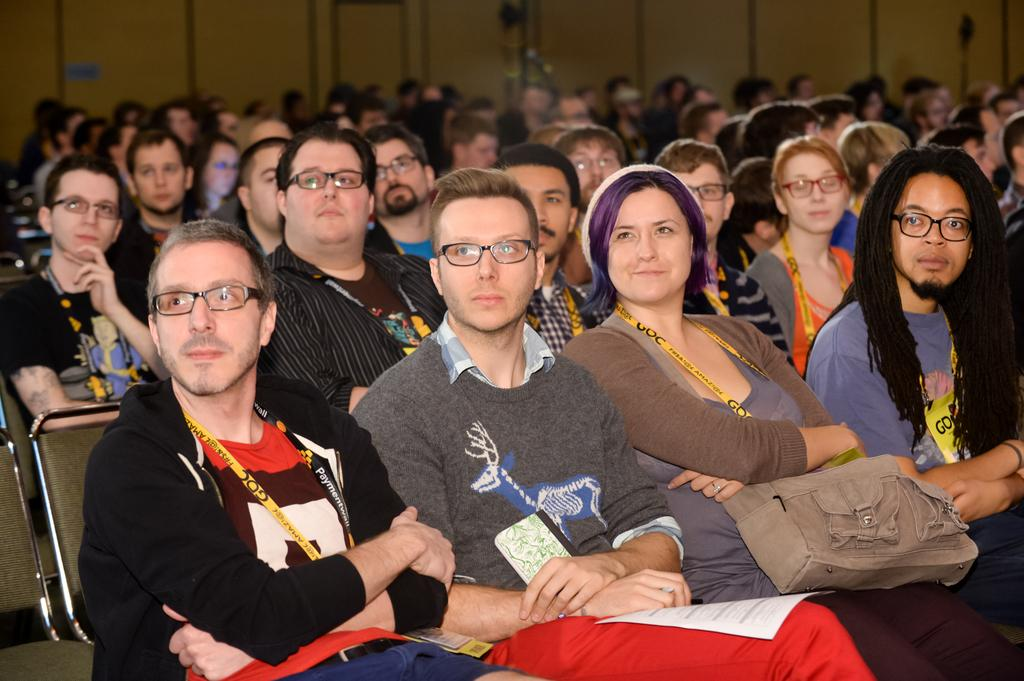What is the main subject of the image? The main subject of the image is a group of people. What are the people in the image doing? The people are sitting on chairs in the image. What items can be seen in the image besides the people? Bags and spectacles are visible in the image. What can be seen in the background of the image? There is a wall in the background of the image. How does the achiever in the image help the woman with her spectacles? There is no achiever or woman present in the image, and therefore no such interaction can be observed. 